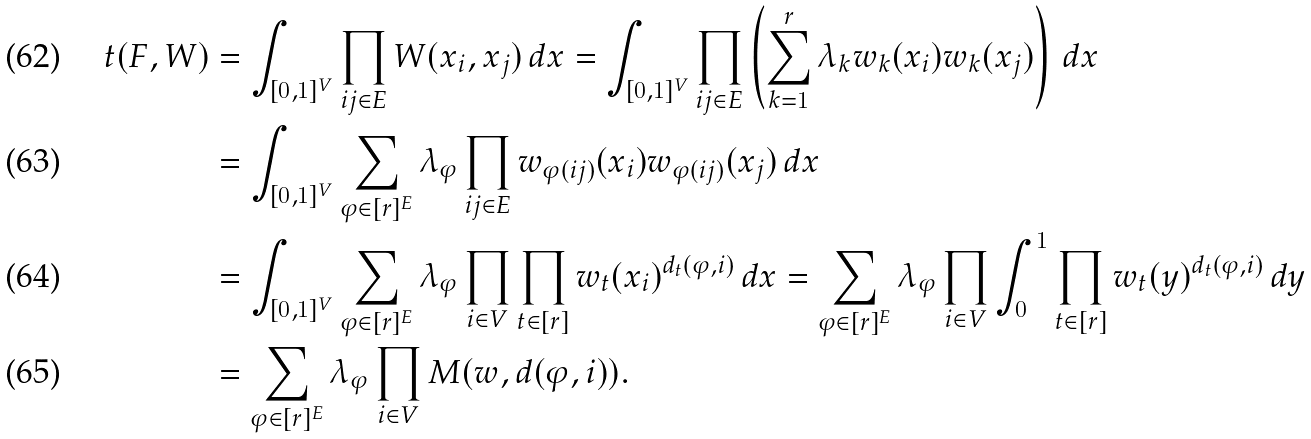<formula> <loc_0><loc_0><loc_500><loc_500>t ( F , W ) & = \int _ { [ 0 , 1 ] ^ { V } } \prod _ { i j \in E } W ( x _ { i } , x _ { j } ) \, d x = \int _ { [ 0 , 1 ] ^ { V } } \prod _ { i j \in E } \left ( \sum _ { k = 1 } ^ { r } \lambda _ { k } w _ { k } ( x _ { i } ) w _ { k } ( x _ { j } ) \right ) \, d x \\ & = \int _ { [ 0 , 1 ] ^ { V } } \sum _ { \varphi \in [ r ] ^ { E } } \lambda _ { \varphi } \prod _ { i j \in E } w _ { \varphi ( i j ) } ( x _ { i } ) w _ { \varphi ( i j ) } ( x _ { j } ) \, d x \\ & = \int _ { [ 0 , 1 ] ^ { V } } \sum _ { \varphi \in [ r ] ^ { E } } \lambda _ { \varphi } \prod _ { i \in V } \prod _ { t \in [ r ] } w _ { t } ( x _ { i } ) ^ { d _ { t } ( \varphi , i ) } \, d x = \sum _ { \varphi \in [ r ] ^ { E } } \lambda _ { \varphi } \prod _ { i \in V } \int _ { 0 } ^ { 1 } \prod _ { t \in [ r ] } w _ { t } ( y ) ^ { d _ { t } ( \varphi , i ) } \, d y \\ & = \sum _ { \varphi \in [ r ] ^ { E } } \lambda _ { \varphi } \prod _ { i \in V } M ( w , d ( \varphi , i ) ) .</formula> 